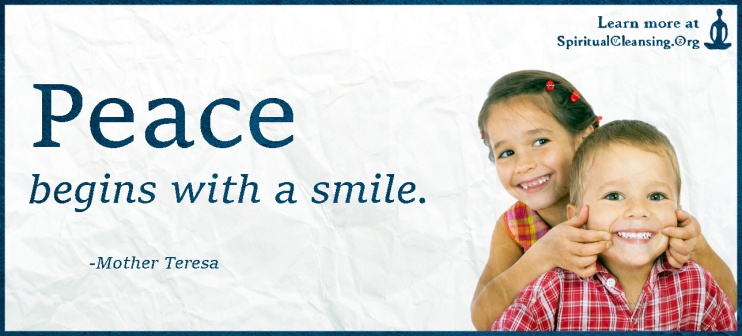What emotions and themes are conveyed by the elements in this picture? The image evokes strong themes of joy, peace, and simplicity. The light blue background with a white texture provides a tranquil and calming effect, setting the stage for the main elements. The quote by Mother Teresa, 'Peace begins with a smile,' written in a dignified serif font, emphasizes the importance of small acts of kindness and positivity. The photograph of the two children—whose expressions are full of genuine happiness and playfulness—reinforces the message of the quote, suggesting that peace and joy are inherently linked and that they can be initiated by something as simple and sincere as a smile. The presence of SpiritualCleansing.org subtly integrates the image’s message with the website’s focus, hinting that the site offers resources or content aimed at fostering such feelings of peace and happiness. How might the image appeal to someone looking for peace or happiness? The visual and textual elements of the image work together to create a compelling appeal to anyone seeking peace or happiness. The quote acts as a gentle reminder that peace is accessible and can start with a simple smile, an everyday action that everyone can perform. The depiction of the children radiating joy and happiness serves as a powerful symbol of innocence and unbridled happiness, evoking a sense of nostalgia and warmth. This combination can resonate with viewers on a deep emotional level, reminding them of the simple pleasures in life and encouraging them to take small steps towards achieving peace and happiness. The discreet mention of SpiritualCleansing.org at the top right corner also suggests a resource where one might find further inspiration and guidance in their quest for peace. Imagine this image as part of a broader campaign. What other elements or messages would complement it to further promote peace and happiness? To create a broader campaign centered around the theme of peace and happiness, this image could be complemented by other visuals and messages such as:
1. **A Series of Quotes:** Featuring various quotes from influential peace advocates and philosophers, visually paired with images of people performing random acts of kindness.
2. **Interactive Content:** Creating engaging content like interactive exercises or games that encourage viewers to practice acts of kindness in their everyday lives.
3. **Real Stories:** Sharing real-life stories and testimonials of individuals who have found peace and happiness through simple changes in their behavior or outlook, illustrated with emotive photography and video.
4. **Mindfulness Resources:** Offering accessible resources for mindfulness and meditation practices, perhaps via video tutorials or downloadable content.
5. **Community Involvement:** Encouraging users to share their own stories and experiences on social media using a specific campaign hashtag, thereby fostering a sense of community and shared commitment to spreading peace and happiness.
6. **Visual Media:** Producing inspirational videos featuring diverse groups of people from around the world, smiling or engaging in joyful activities, further emphasizing the universal nature of the campaign's message. 